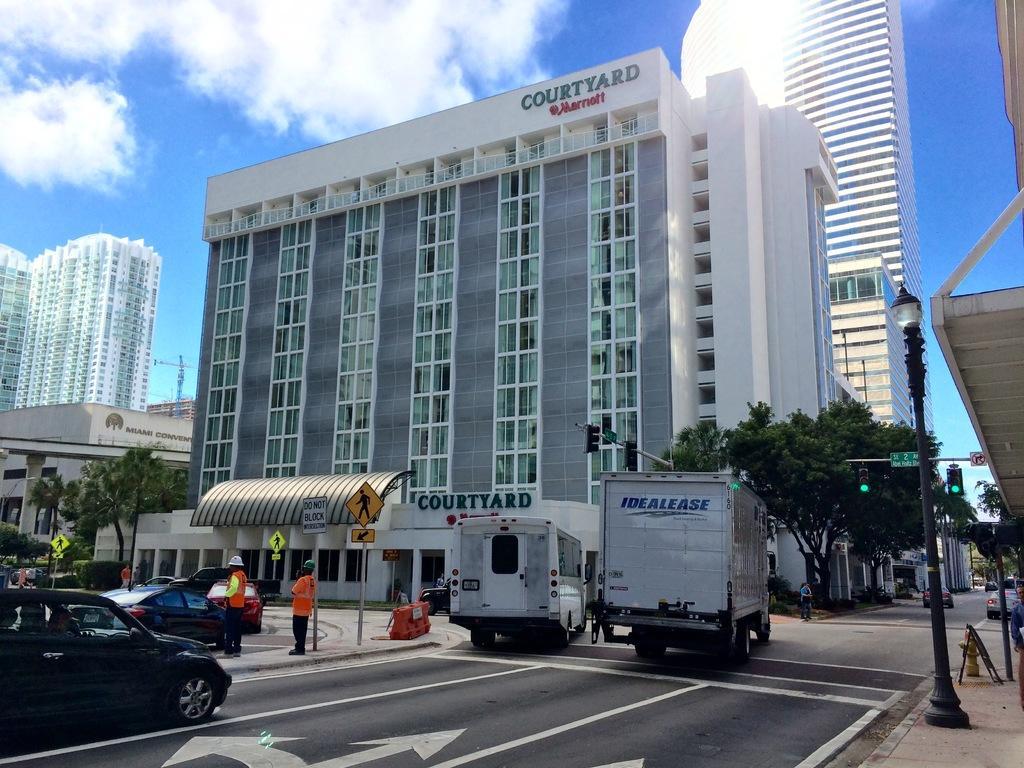How would you summarize this image in a sentence or two? In the foreground of the picture I can see the vehicles on the road. There is a decorative light pole on the side of the road and it is on the right side. I can see the cautious board poles and barricade on the side of the road. In the background, I can see the buildings and trees. There are clouds in the sky. I can see two men standing on the side of the road and they are wearing the safety jacket. 